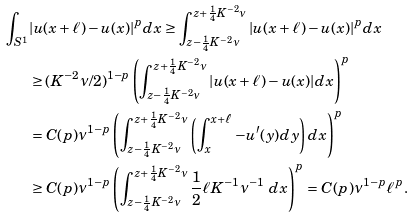<formula> <loc_0><loc_0><loc_500><loc_500>\int _ { S ^ { 1 } } & { | u ( x + \ell ) - u ( x ) | ^ { p } d x } \geq \int _ { z - \frac { 1 } { 4 } K ^ { - 2 } \nu } ^ { z + \frac { 1 } { 4 } K ^ { - 2 } \nu } { | u ( x + \ell ) - u ( x ) | ^ { p } d x } \\ & \geq ( K ^ { - 2 } \nu / 2 ) ^ { 1 - p } \left ( \int _ { z - \frac { 1 } { 4 } K ^ { - 2 } \nu } ^ { z + \frac { 1 } { 4 } K ^ { - 2 } \nu } { | u ( x + \ell ) - u ( x ) | d x } \right ) ^ { p } \\ & = C ( p ) \nu ^ { 1 - p } \left ( \int _ { z - \frac { 1 } { 4 } K ^ { - 2 } \nu } ^ { z + \frac { 1 } { 4 } K ^ { - 2 } \nu } { \left ( \int _ { x } ^ { x + \ell } { - u ^ { \prime } ( y ) d y } \right ) d x } \right ) ^ { p } \\ & \geq C ( p ) \nu ^ { 1 - p } \left ( \int _ { z - \frac { 1 } { 4 } K ^ { - 2 } \nu } ^ { z + \frac { 1 } { 4 } K ^ { - 2 } \nu } { \frac { 1 } { 2 } \ell K ^ { - 1 } \nu ^ { - 1 } \ d x } \right ) ^ { p } = C ( p ) \nu ^ { 1 - p } \ell ^ { p } .</formula> 